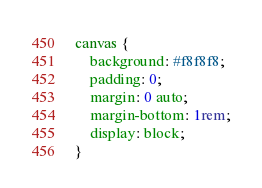Convert code to text. <code><loc_0><loc_0><loc_500><loc_500><_CSS_>canvas {
    background: #f8f8f8;
    padding: 0;
    margin: 0 auto;
    margin-bottom: 1rem;
    display: block;
}</code> 